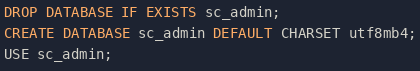<code> <loc_0><loc_0><loc_500><loc_500><_SQL_>DROP DATABASE IF EXISTS sc_admin;
CREATE DATABASE sc_admin DEFAULT CHARSET utf8mb4;
USE sc_admin;</code> 